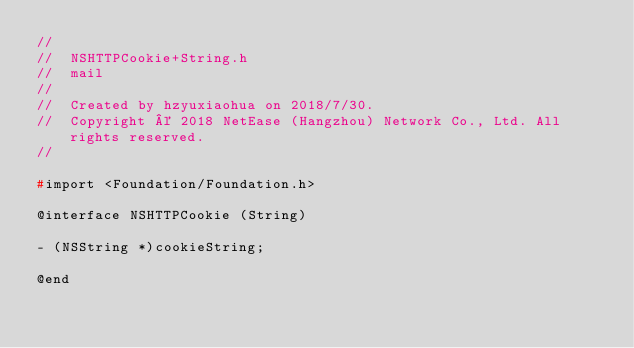Convert code to text. <code><loc_0><loc_0><loc_500><loc_500><_C_>//
//  NSHTTPCookie+String.h
//  mail
//
//  Created by hzyuxiaohua on 2018/7/30.
//  Copyright © 2018 NetEase (Hangzhou) Network Co., Ltd. All rights reserved.
//

#import <Foundation/Foundation.h>

@interface NSHTTPCookie (String)

- (NSString *)cookieString;

@end
</code> 